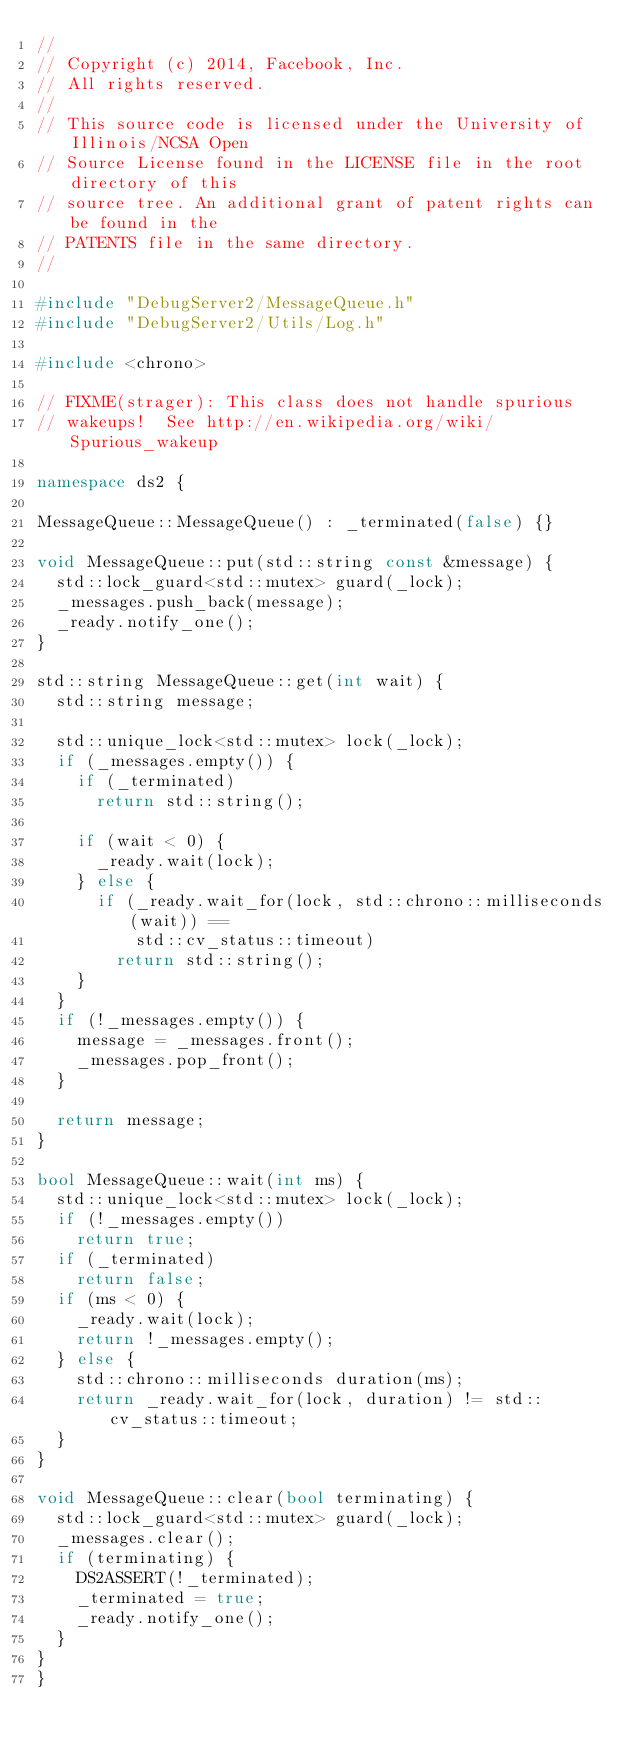<code> <loc_0><loc_0><loc_500><loc_500><_C++_>//
// Copyright (c) 2014, Facebook, Inc.
// All rights reserved.
//
// This source code is licensed under the University of Illinois/NCSA Open
// Source License found in the LICENSE file in the root directory of this
// source tree. An additional grant of patent rights can be found in the
// PATENTS file in the same directory.
//

#include "DebugServer2/MessageQueue.h"
#include "DebugServer2/Utils/Log.h"

#include <chrono>

// FIXME(strager): This class does not handle spurious
// wakeups!  See http://en.wikipedia.org/wiki/Spurious_wakeup

namespace ds2 {

MessageQueue::MessageQueue() : _terminated(false) {}

void MessageQueue::put(std::string const &message) {
  std::lock_guard<std::mutex> guard(_lock);
  _messages.push_back(message);
  _ready.notify_one();
}

std::string MessageQueue::get(int wait) {
  std::string message;

  std::unique_lock<std::mutex> lock(_lock);
  if (_messages.empty()) {
    if (_terminated)
      return std::string();

    if (wait < 0) {
      _ready.wait(lock);
    } else {
      if (_ready.wait_for(lock, std::chrono::milliseconds(wait)) ==
          std::cv_status::timeout)
        return std::string();
    }
  }
  if (!_messages.empty()) {
    message = _messages.front();
    _messages.pop_front();
  }

  return message;
}

bool MessageQueue::wait(int ms) {
  std::unique_lock<std::mutex> lock(_lock);
  if (!_messages.empty())
    return true;
  if (_terminated)
    return false;
  if (ms < 0) {
    _ready.wait(lock);
    return !_messages.empty();
  } else {
    std::chrono::milliseconds duration(ms);
    return _ready.wait_for(lock, duration) != std::cv_status::timeout;
  }
}

void MessageQueue::clear(bool terminating) {
  std::lock_guard<std::mutex> guard(_lock);
  _messages.clear();
  if (terminating) {
    DS2ASSERT(!_terminated);
    _terminated = true;
    _ready.notify_one();
  }
}
}
</code> 